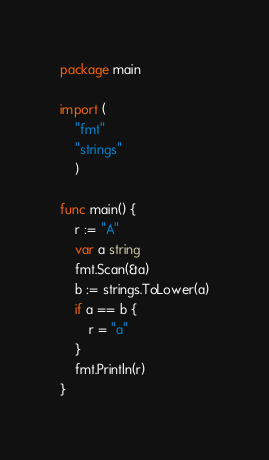<code> <loc_0><loc_0><loc_500><loc_500><_Go_>package main

import (
	"fmt"
	"strings"
	)

func main() {
	r := "A"
	var a string
	fmt.Scan(&a)
	b := strings.ToLower(a)
	if a == b {
		r = "a"
	}
	fmt.Println(r)
}</code> 